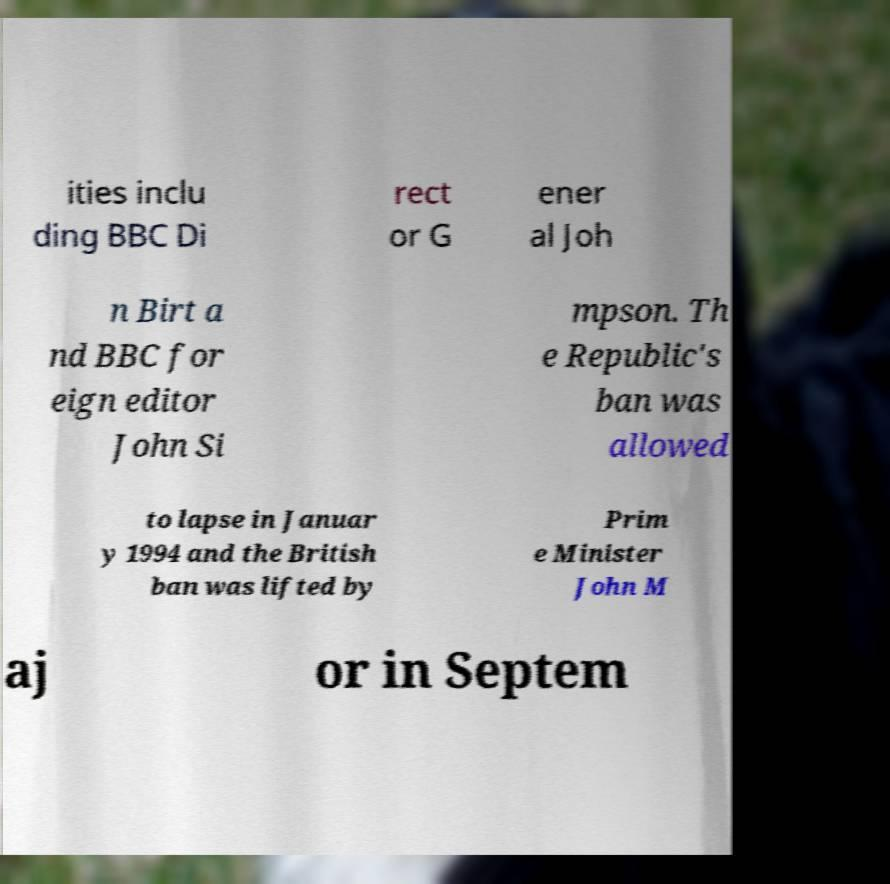Can you read and provide the text displayed in the image?This photo seems to have some interesting text. Can you extract and type it out for me? ities inclu ding BBC Di rect or G ener al Joh n Birt a nd BBC for eign editor John Si mpson. Th e Republic's ban was allowed to lapse in Januar y 1994 and the British ban was lifted by Prim e Minister John M aj or in Septem 